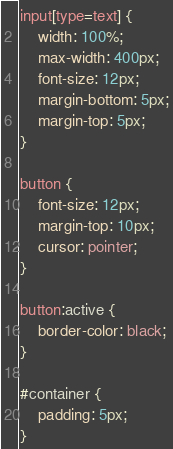Convert code to text. <code><loc_0><loc_0><loc_500><loc_500><_CSS_>input[type=text] {
    width: 100%;
    max-width: 400px;
    font-size: 12px;
    margin-bottom: 5px;
    margin-top: 5px;
}

button {
    font-size: 12px;
    margin-top: 10px;
    cursor: pointer;
}

button:active {
    border-color: black;
}

#container {
    padding: 5px;
}
</code> 